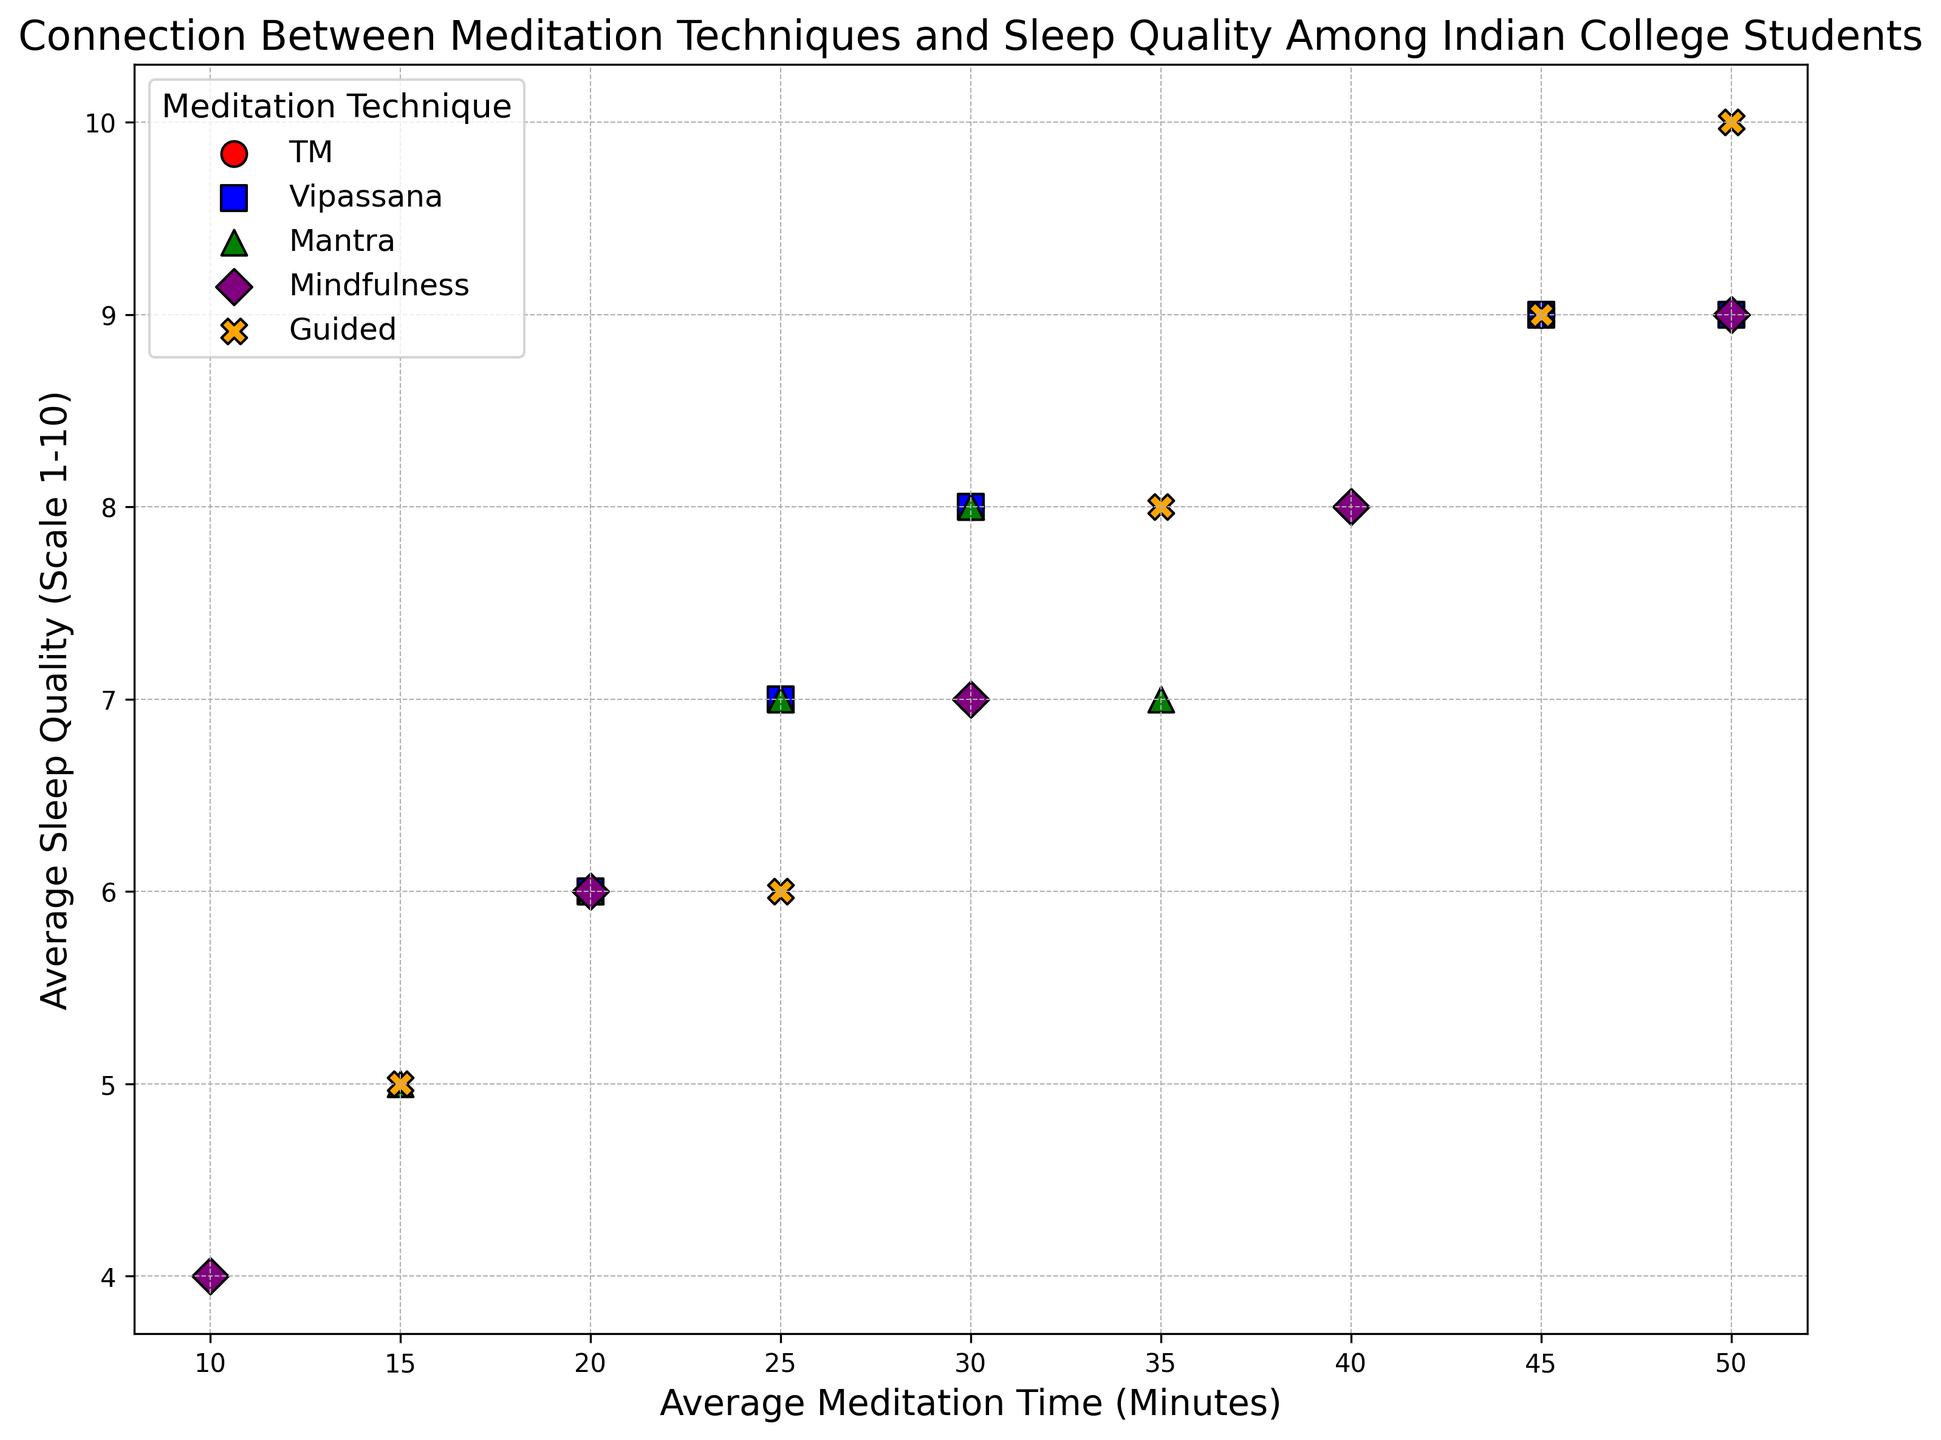What's the highest sleep quality rating for TM? By examining the scatter plot, we can identify the highest point corresponding to TM. This corresponds to a sleep quality rating of 9.
Answer: 9 Which meditation technique has the widest range of meditation times? Checking the scatter plot, we notice that Mindfulness has data points ranging from 10 to 50 minutes, which spans the widest range of meditation times.
Answer: Mindfulness Compare the average sleep quality between Mantra and Vipassana techniques. Which one has higher sleep quality? By visually comparing the data points for Mantra and Vipassana, we see that Vipassana generally has higher sleep quality ratings.
Answer: Vipassana How many meditation techniques have at least one instance with a sleep quality of 9 or above? Observing the scatter plot, we can note that TM, Vipassana, Mindfulness, and Guided techniques all have at least one data point featuring a sleep quality of 9 or above.
Answer: 4 What is the difference in average sleep quality between the meditation technique with the highest average time and the one with the lowest? Identifying the average meditation times, Mindfulness has the greatest (50 minutes) and Mantra has the smallest (15 minutes). By comparing their average sleep qualities, we see Mindfulness ranges 4 to 9, whereas Mantra's sleep quality ranges 5 to 8. The difference between their highest sleep qualities is 9 - 8 = 1.
Answer: 1 What color represents the Vipassana technique in the figure? By looking at the legend or identifying the respective scatter points for Vipassana, we can see that they are marked in blue.
Answer: Blue Which technique has a more even spread in the sleep quality ratings for different meditation times? Comparing the dispersion of data points across sleep quality ratings, Mindfulness seems to have a relatively even spread from 4 to 9.
Answer: Mindfulness What is the average sleep quality for guided meditation with 50 minutes of average meditation time? Examining the data points for Guided meditation, the data point with 50 minutes of meditation has a sleep quality value of 10.
Answer: 10 How do Guided and TM techniques compare in terms of the highest observed sleep quality? Observing the highest points for sleep quality, Guided meditation has a rating of 10 while TM has a maximum rating of 9.
Answer: Guided has higher maximum sleep quality 